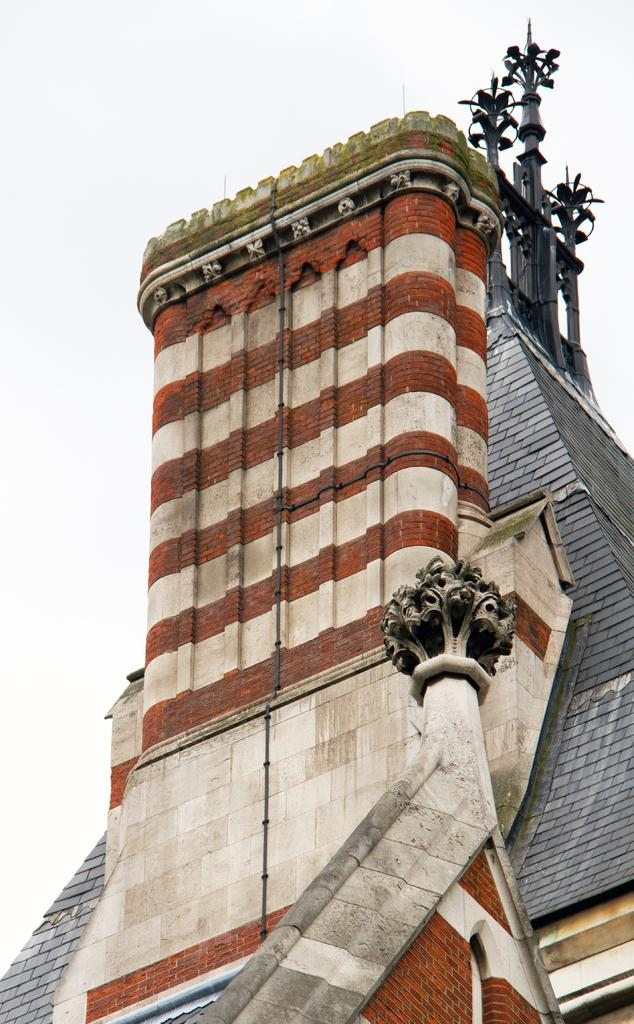What type of structures can be seen in the background of the image? A: There are buildings in the background of the image. What else is visible in the background of the image besides the buildings? The sky is visible in the background of the image. What type of tooth is growing in the image? There is no tooth present in the image. How does the growth of the tooth affect the structure of the buildings in the image? There is no tooth present in the image, so its growth does not affect the structure of the buildings. 